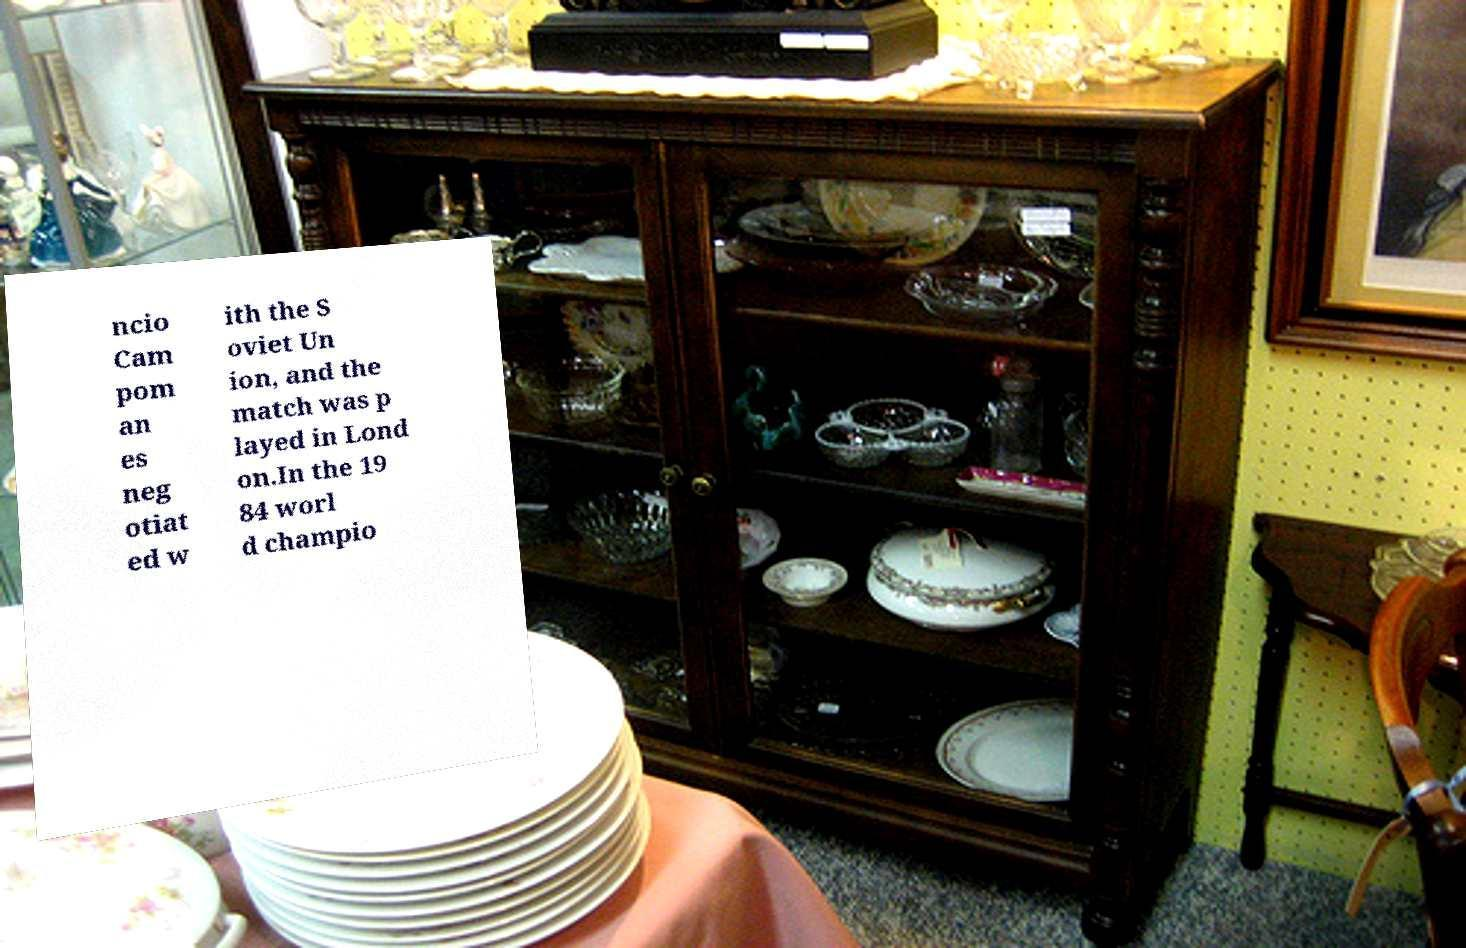What messages or text are displayed in this image? I need them in a readable, typed format. ncio Cam pom an es neg otiat ed w ith the S oviet Un ion, and the match was p layed in Lond on.In the 19 84 worl d champio 